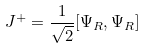<formula> <loc_0><loc_0><loc_500><loc_500>J ^ { + } = { \frac { 1 } { \sqrt { 2 } } } [ \Psi _ { R } , \Psi _ { R } ]</formula> 